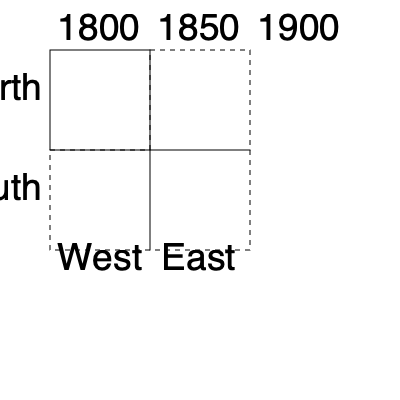Based on the urban expansion diagram, which direction did the town grow the least between 1800 and 1900? To determine the direction of least growth, we need to analyze the expansion pattern shown in the diagram:

1. The solid black square represents the original town layout in 1800.
2. The dashed lines indicate expansion areas by 1900.
3. Expansion occurred in three directions: East, South, and Southeast.
4. The North direction shows no expansion beyond the original 1800 boundary.
5. The West direction also shows no expansion beyond the original 1800 boundary.

Comparing the growth in all directions:
- North: No growth
- South: One unit of growth
- East: One unit of growth
- West: No growth
- Southeast: One unit of growth (diagonal)

Both North and West show no growth, while all other directions show some expansion. Therefore, the town grew least in both the North and West directions.
Answer: North and West 